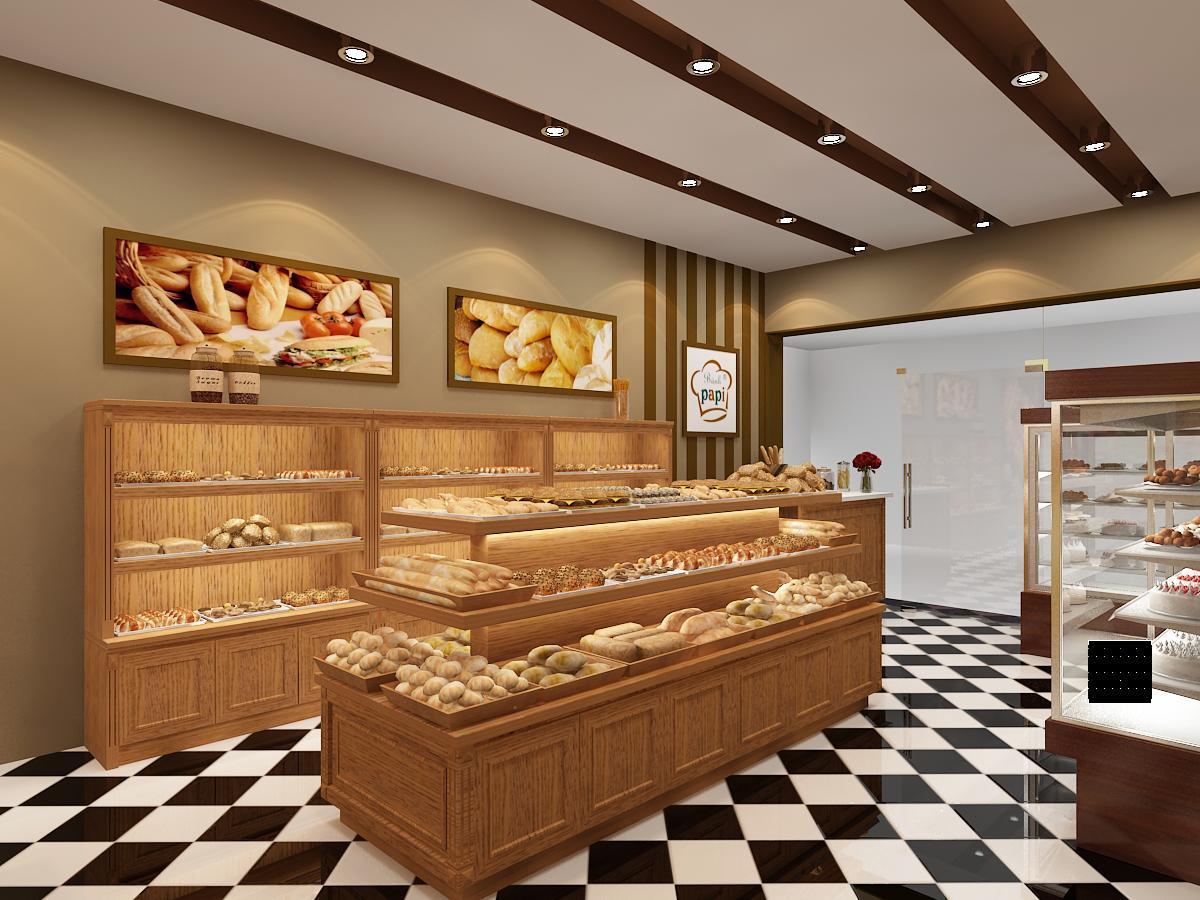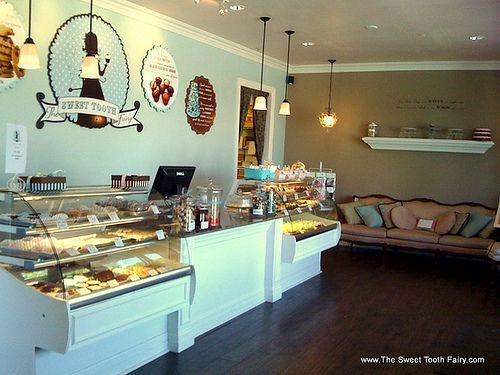The first image is the image on the left, the second image is the image on the right. Examine the images to the left and right. Is the description "One image shows a small seating area for customers." accurate? Answer yes or no. Yes. The first image is the image on the left, the second image is the image on the right. Considering the images on both sides, is "There are hanging lights above the counter in one of the images." valid? Answer yes or no. Yes. 